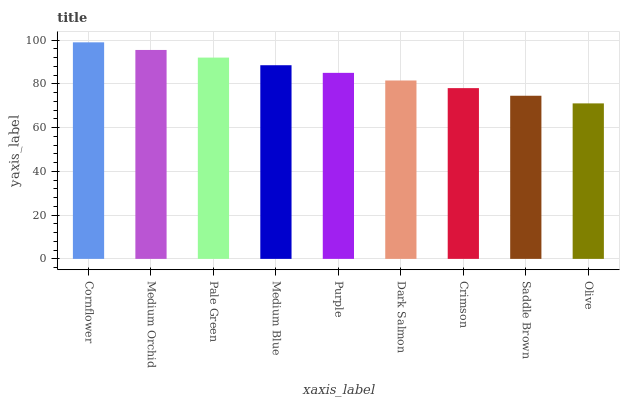Is Olive the minimum?
Answer yes or no. Yes. Is Cornflower the maximum?
Answer yes or no. Yes. Is Medium Orchid the minimum?
Answer yes or no. No. Is Medium Orchid the maximum?
Answer yes or no. No. Is Cornflower greater than Medium Orchid?
Answer yes or no. Yes. Is Medium Orchid less than Cornflower?
Answer yes or no. Yes. Is Medium Orchid greater than Cornflower?
Answer yes or no. No. Is Cornflower less than Medium Orchid?
Answer yes or no. No. Is Purple the high median?
Answer yes or no. Yes. Is Purple the low median?
Answer yes or no. Yes. Is Olive the high median?
Answer yes or no. No. Is Saddle Brown the low median?
Answer yes or no. No. 